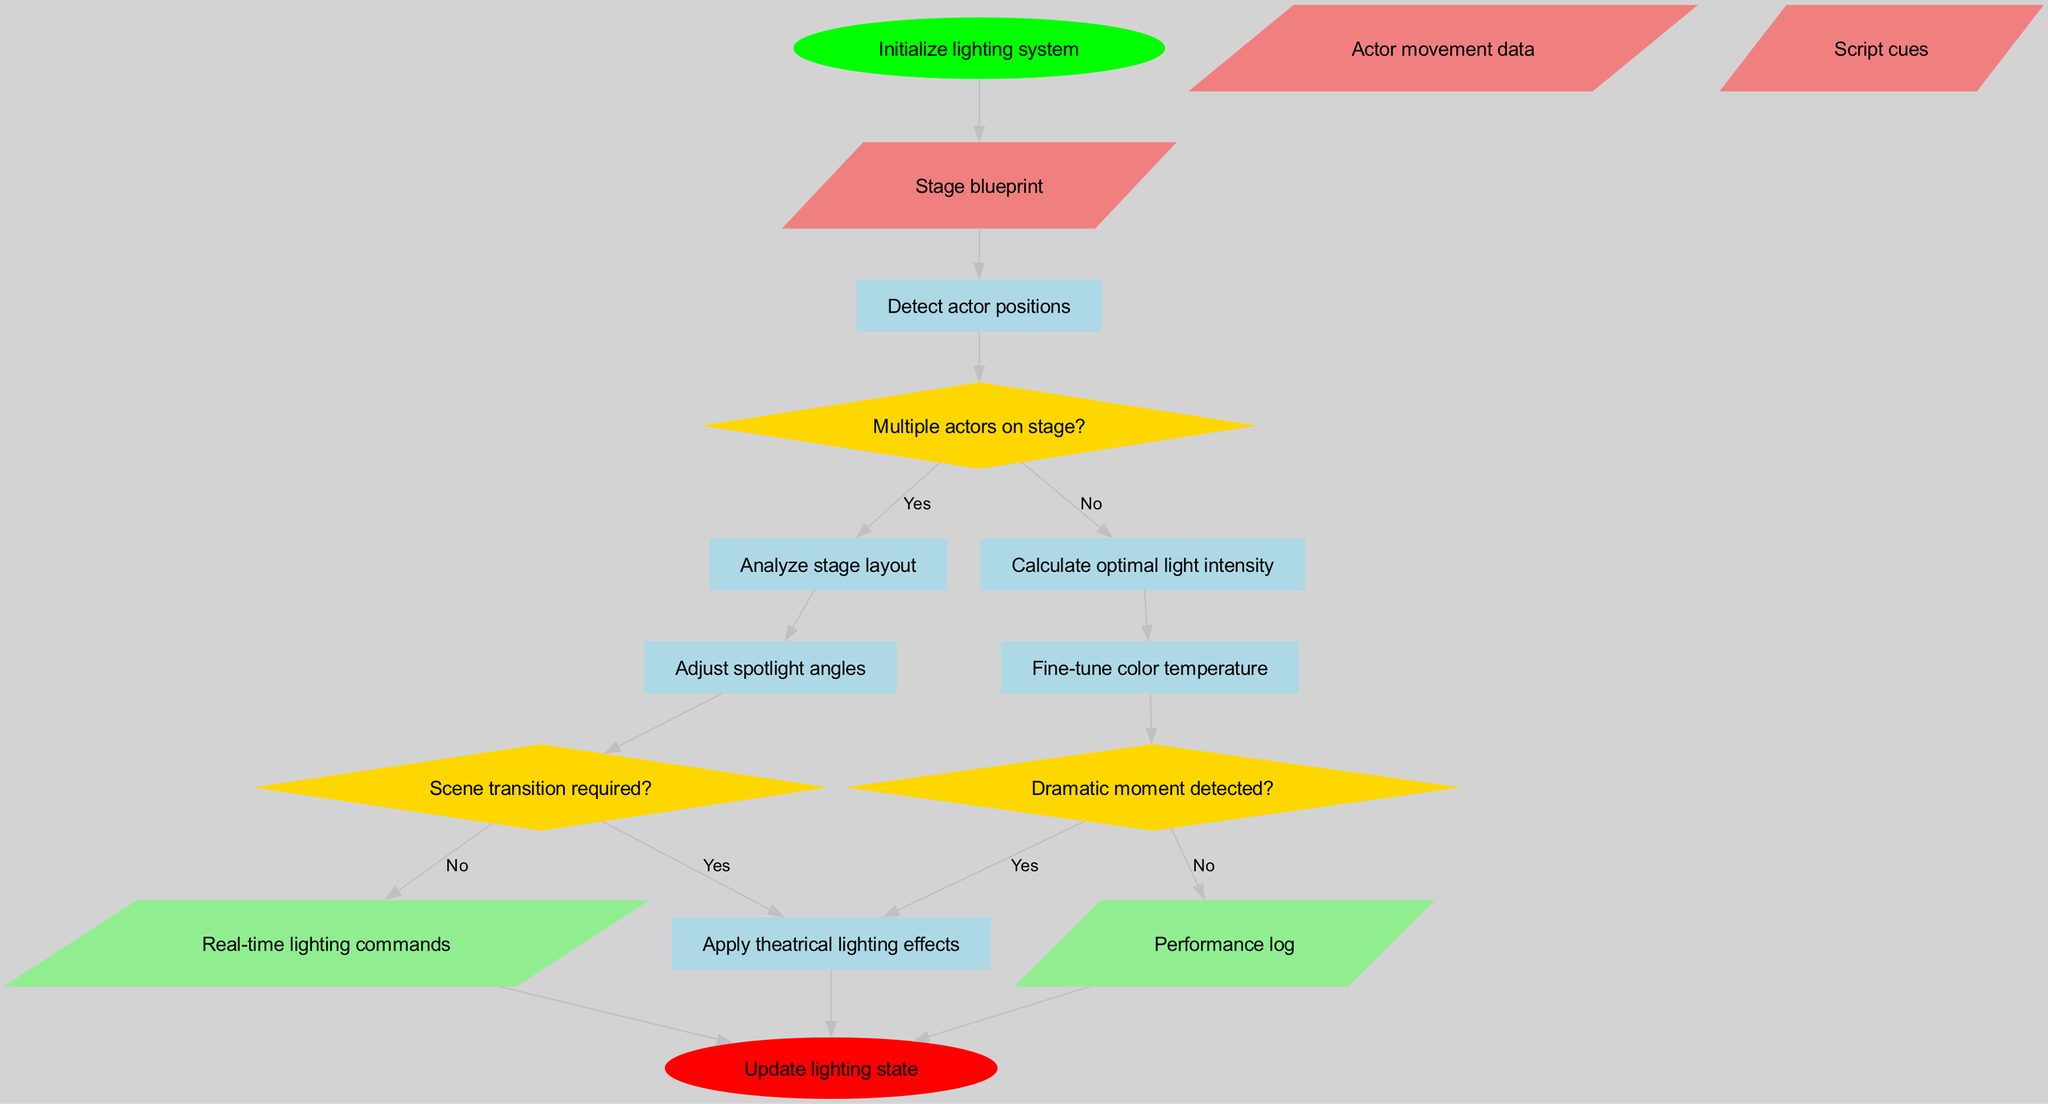What is the start node of the diagram? The start node is explicitly labeled in the diagram as "Initialize lighting system". Therefore, the answer is derived directly from the node at the beginning of the flowchart.
Answer: Initialize lighting system How many processes are depicted in the diagram? The diagram contains six processes, which are explicitly listed. Counting each labeled process node confirms this total.
Answer: 6 What are the first two data inputs in the diagram? The data inputs are labeled as "Stage blueprint", "Actor movement data", and "Script cues". The first two inputs are located at the top of the input section.
Answer: Stage blueprint, Actor movement data What happens if the decision "Multiple actors on stage?" is answered with "No"? If "No" is selected for this decision, the flowchart indicates movement to the process "Calculate optimal light intensity". This shows how the decision influences the flow of operations.
Answer: Calculate optimal light intensity Which process connects to the decision "Dramatic moment detected?"? The process "Fine-tune color temperature" directly leads to the decision "Dramatic moment detected?". By tracing the flow of the diagram, we see this connection clearly labeled.
Answer: Fine-tune color temperature What is the output if "Dramatic moment detected?" is answered with "No"? If the answer is "No", the flowchart indicates that the process reports to "Apply theatrical lighting effects", leading to a specific lighting action without further decisions.
Answer: Apply theatrical lighting effects What type of node is "Adjust spotlight angles"? The node "Adjust spotlight angles" is classified as a process in the diagram. It is visually represented in a rectangular, filled style distinguishable from other node types.
Answer: Process How many decision nodes are there in the flowchart? There are three decision nodes present in the diagram, as labeled and distinctly shaped in diamond form. Their count contributes to the decision-making flow in the algorithm.
Answer: 3 What happens at the end of the diagram? The end of the diagram specifies that the last operation is "Update lighting state". This indicates the conclusion of the algorithm's process flow, encapsulated in the terminating node.
Answer: Update lighting state 